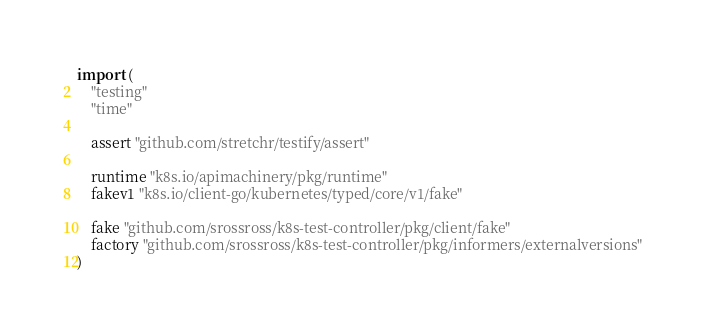Convert code to text. <code><loc_0><loc_0><loc_500><loc_500><_Go_>
import (
	"testing"
	"time"

	assert "github.com/stretchr/testify/assert"

	runtime "k8s.io/apimachinery/pkg/runtime"
	fakev1 "k8s.io/client-go/kubernetes/typed/core/v1/fake"

	fake "github.com/srossross/k8s-test-controller/pkg/client/fake"
	factory "github.com/srossross/k8s-test-controller/pkg/informers/externalversions"
)
</code> 